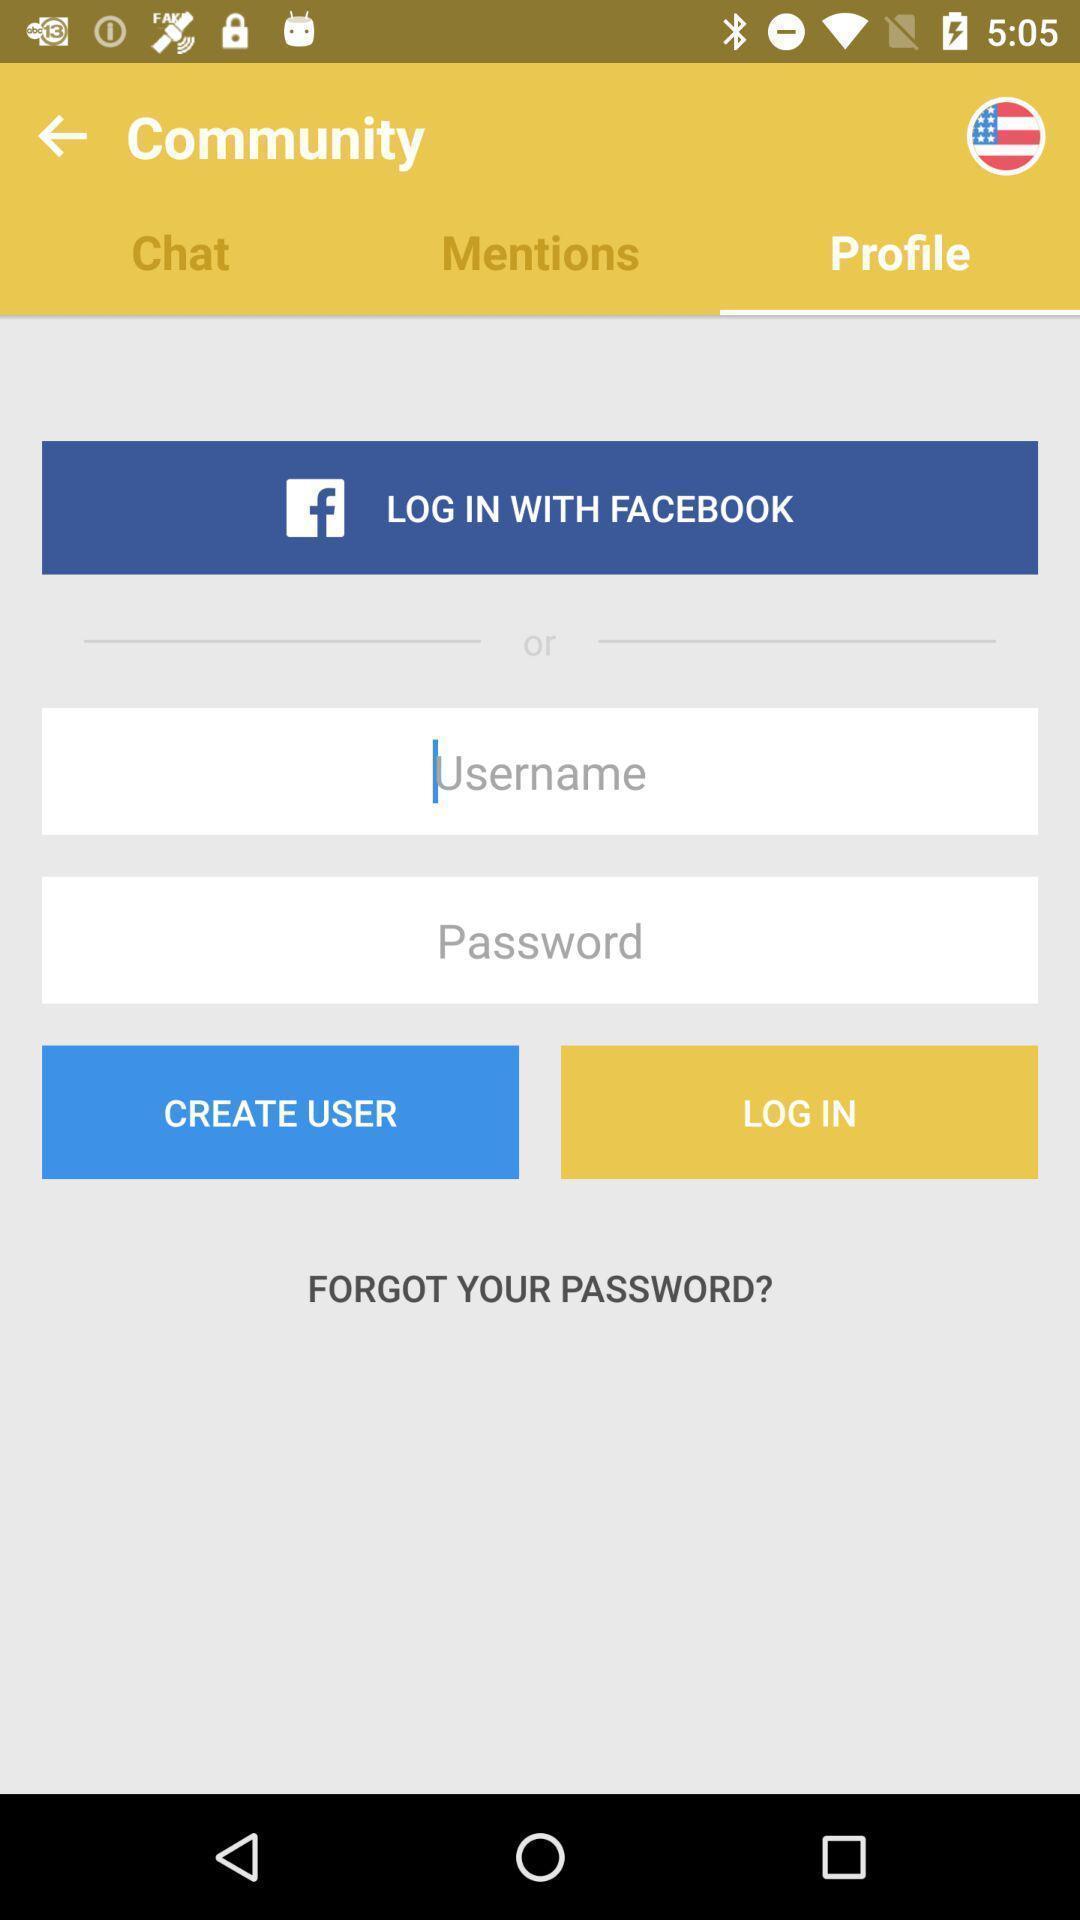Explain the elements present in this screenshot. Welcome page with login options for a 'quit smoking app. 